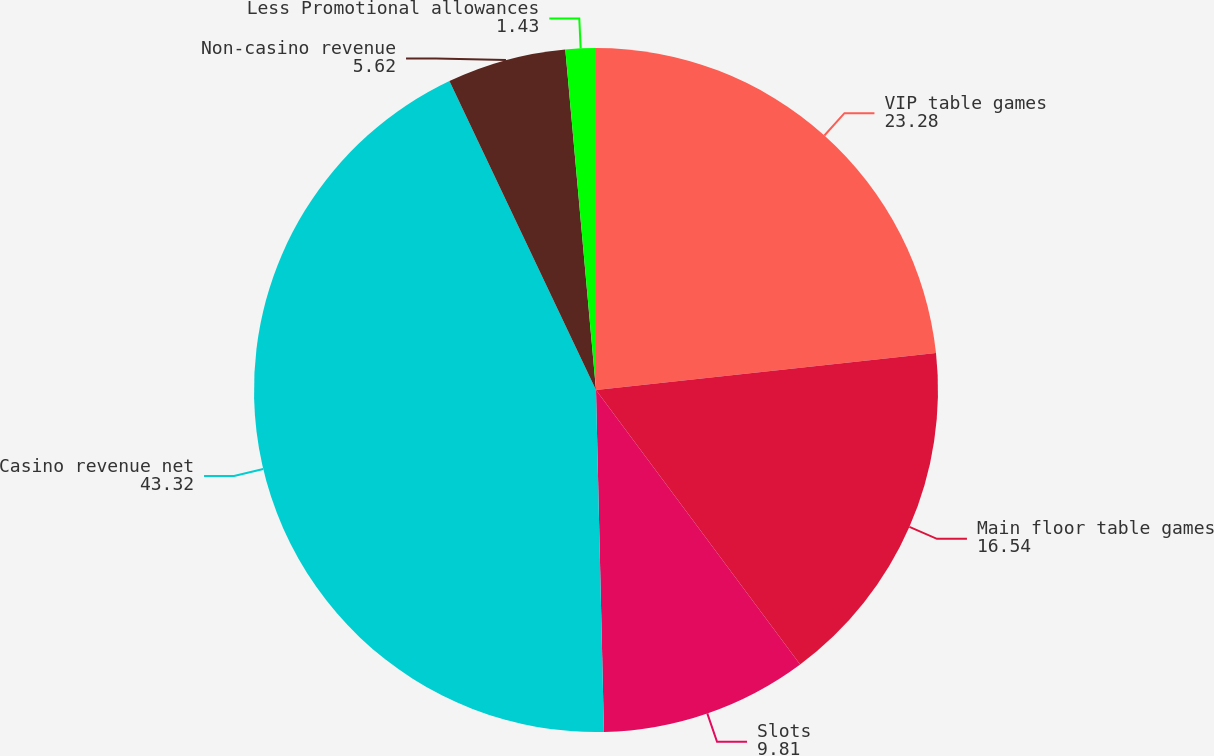Convert chart to OTSL. <chart><loc_0><loc_0><loc_500><loc_500><pie_chart><fcel>VIP table games<fcel>Main floor table games<fcel>Slots<fcel>Casino revenue net<fcel>Non-casino revenue<fcel>Less Promotional allowances<nl><fcel>23.28%<fcel>16.54%<fcel>9.81%<fcel>43.32%<fcel>5.62%<fcel>1.43%<nl></chart> 